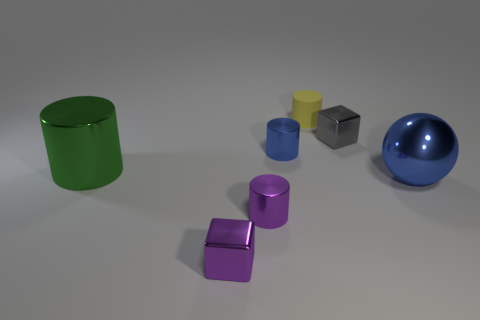What number of things are either shiny objects that are on the right side of the yellow cylinder or large cyan rubber cylinders?
Provide a short and direct response. 2. Is the material of the big cylinder the same as the tiny cylinder that is behind the gray block?
Ensure brevity in your answer.  No. What number of other things are the same shape as the large green object?
Your answer should be compact. 3. What number of objects are either small objects in front of the green cylinder or yellow matte cylinders that are behind the large green cylinder?
Your response must be concise. 3. How many other objects are the same color as the rubber cylinder?
Make the answer very short. 0. Is the number of purple things right of the gray cube less than the number of big metallic objects to the right of the small yellow thing?
Your response must be concise. Yes. What number of tiny purple objects are there?
Your response must be concise. 2. Are there any other things that have the same material as the gray block?
Your response must be concise. Yes. There is a big object that is the same shape as the small blue object; what is its material?
Provide a succinct answer. Metal. Are there fewer blue metal cylinders behind the gray block than big metal balls?
Offer a very short reply. Yes. 